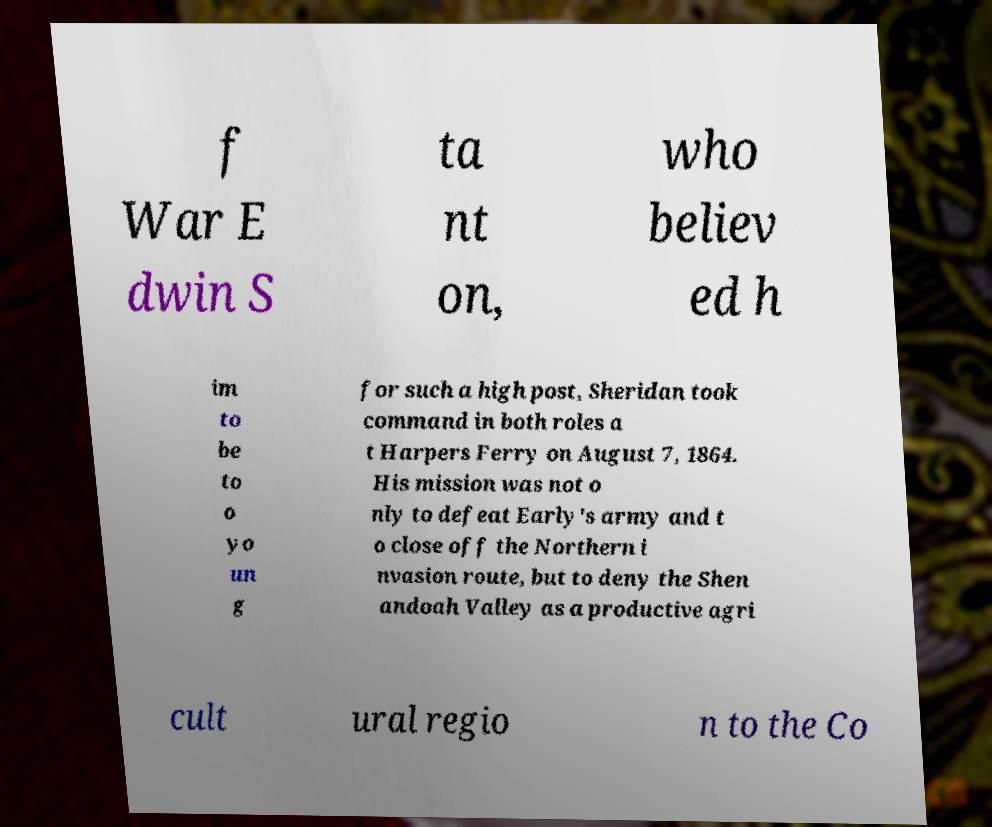What messages or text are displayed in this image? I need them in a readable, typed format. f War E dwin S ta nt on, who believ ed h im to be to o yo un g for such a high post, Sheridan took command in both roles a t Harpers Ferry on August 7, 1864. His mission was not o nly to defeat Early's army and t o close off the Northern i nvasion route, but to deny the Shen andoah Valley as a productive agri cult ural regio n to the Co 